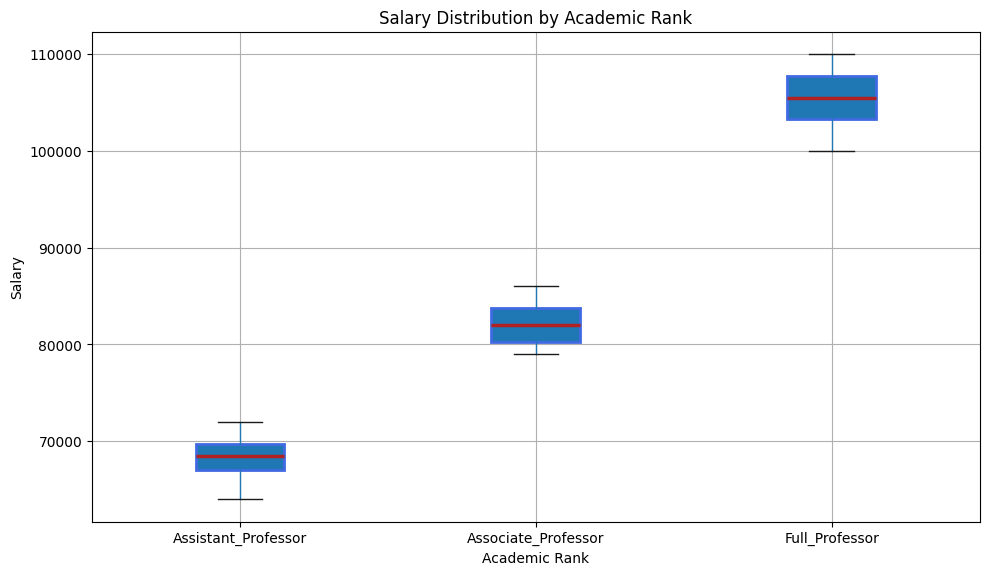What's the median salary for Associate Professors? To find the median salary for Associate Professors, locate the horizontal line inside the box for the Associate Professors' category. This line represents the median salary.
Answer: 82000 Which academic rank has the highest median salary? Compare the locations of the horizontal lines inside each box plot. The box plot with the highest horizontal line will correspond to the academic rank with the highest median salary.
Answer: Full Professor What is the interquartile range (IQR) for Assistant Professors? The IQR is the range between the first quartile (Q1) and the third quartile (Q3). Locate the bottom and top lines of the box for Assistant Professors; these lines represent Q1 and Q3, respectively. Subtract Q1 from Q3 to get the IQR.
Answer: 7000 How does the variability in salaries compare between Assistant Professors and Full Professors? Look at the width of the interquartile range (the height of the box) for each of the two categories. A taller box indicates higher variability. Observe which box is taller to determine which has more variability.
Answer: Assistant Professors have more variability Are there any outliers in the salary distribution for Full Professors? Outliers are represented by individual points outside the whiskers of the box plot. Look for any points outside the whiskers of the Full Professors' box plot.
Answer: No Which academic rank shows the smallest range in salaries? The range in salaries is represented by the total length covered by the whiskers and the box of a box plot. Compare the overall length from the minimum to the maximum salary for each academic rank. The smallest range will have the shortest total length.
Answer: Associate Professor Which academic rank has a box plot with the widest interquartile range (IQR)? Compare the heights of the boxes for each of the academic ranks. The box with the largest difference between Q1 and Q3 has the widest IQR.
Answer: Assistant Professor Between which two academic ranks is the difference in median salaries the greatest? Look at the median lines inside the boxes for each academic rank and compare their positions. Identify which two medians have the largest vertical distance between them.
Answer: Associate Professor and Full Professor What is the upper whisker value for the salaries of Full Professors? The upper whisker is the highest line extending from the top of the box. Locate the top point of the upper whisker for Full Professors to find this value.
Answer: 110000 